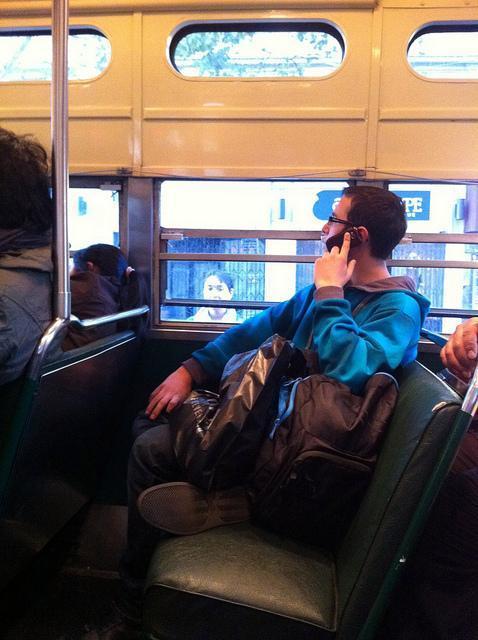How many people are shown on the ride?
Give a very brief answer. 4. How many people can you see?
Give a very brief answer. 3. 